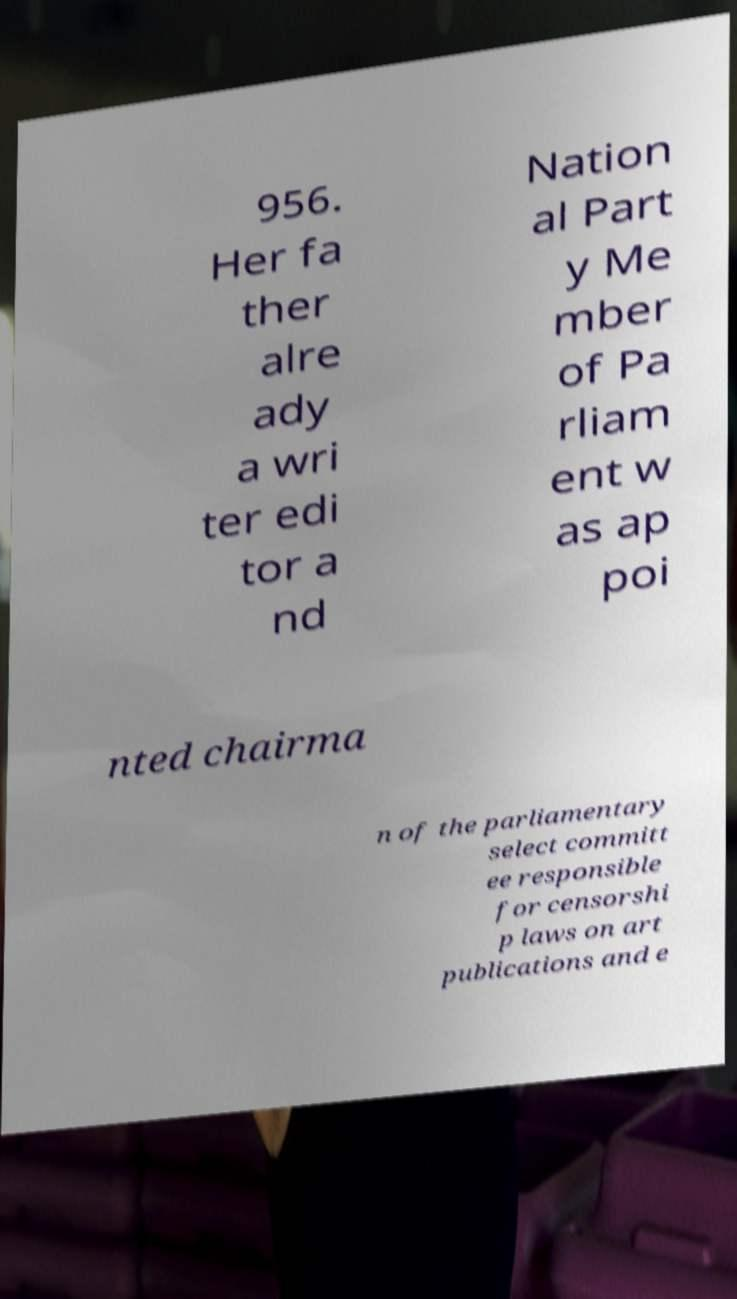There's text embedded in this image that I need extracted. Can you transcribe it verbatim? 956. Her fa ther alre ady a wri ter edi tor a nd Nation al Part y Me mber of Pa rliam ent w as ap poi nted chairma n of the parliamentary select committ ee responsible for censorshi p laws on art publications and e 